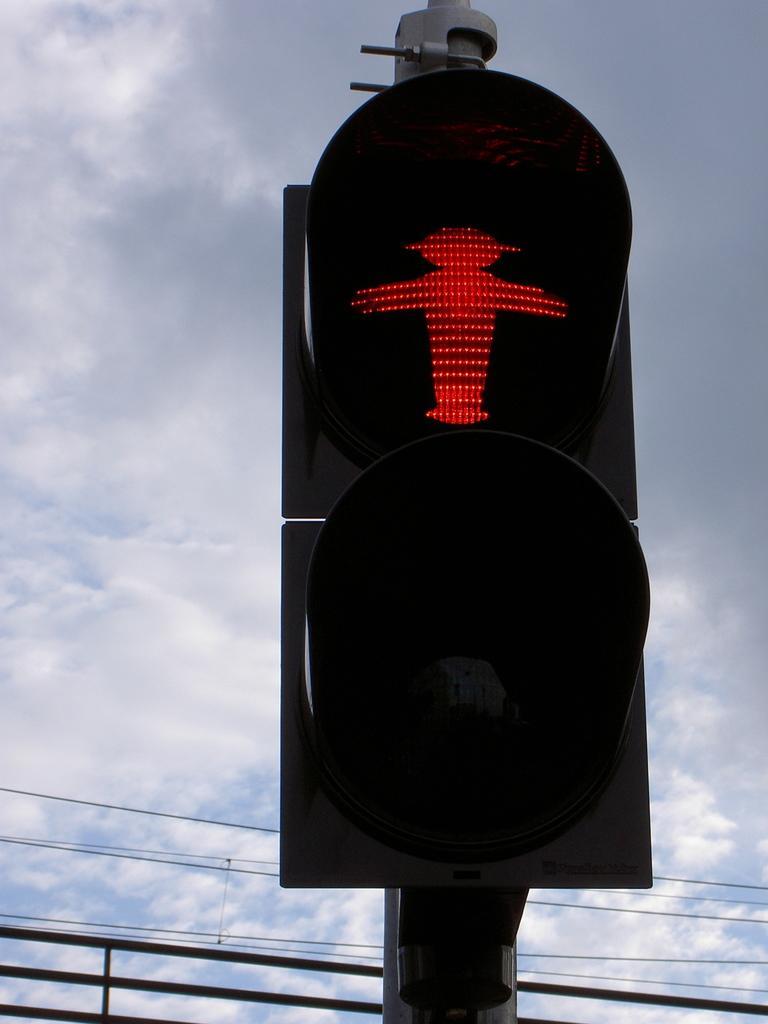In one or two sentences, can you explain what this image depicts? In this image I can see there is a traffic light, there are red color lights displayed and in the backdrop there is a railing, cables and the sky is cloudy. 